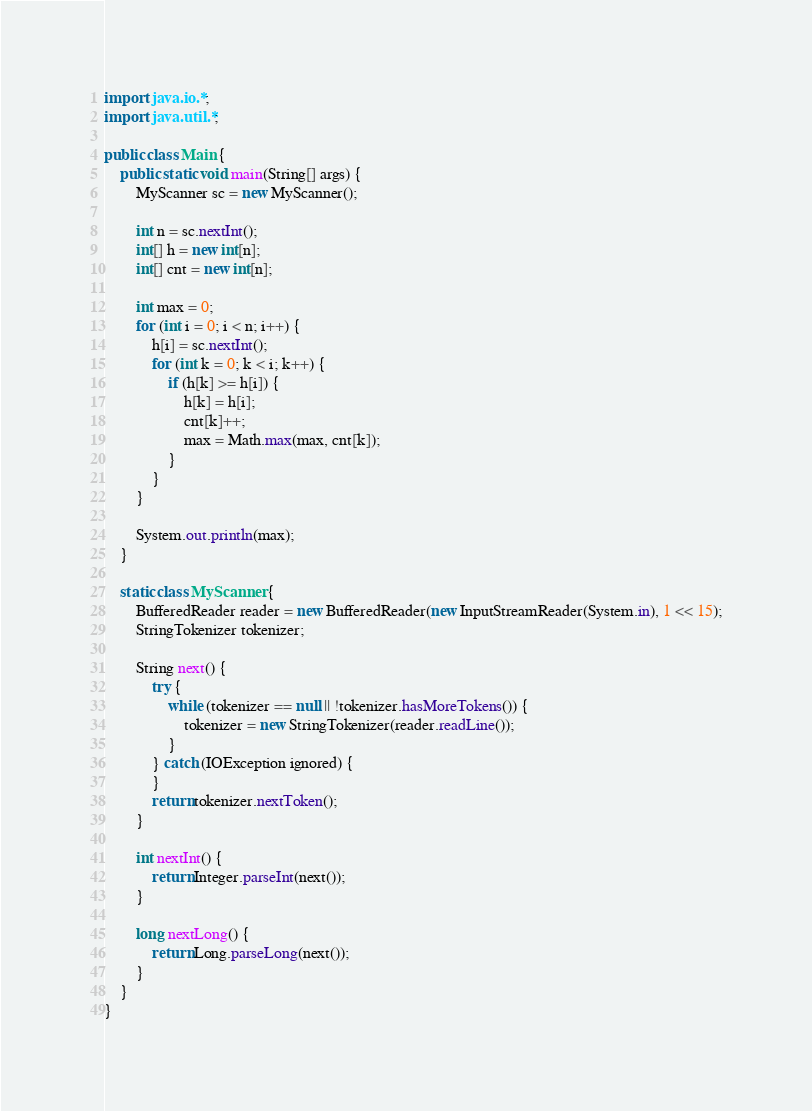Convert code to text. <code><loc_0><loc_0><loc_500><loc_500><_Java_>import java.io.*;
import java.util.*;

public class Main {
    public static void main(String[] args) {
        MyScanner sc = new MyScanner();

        int n = sc.nextInt();
        int[] h = new int[n];
        int[] cnt = new int[n];

        int max = 0;
        for (int i = 0; i < n; i++) {
            h[i] = sc.nextInt();
            for (int k = 0; k < i; k++) {
                if (h[k] >= h[i]) {
                    h[k] = h[i];
                    cnt[k]++;
                    max = Math.max(max, cnt[k]);
                }
            }
        }

        System.out.println(max);
    }

    static class MyScanner {
        BufferedReader reader = new BufferedReader(new InputStreamReader(System.in), 1 << 15);
        StringTokenizer tokenizer;

        String next() {
            try {
                while (tokenizer == null || !tokenizer.hasMoreTokens()) {
                    tokenizer = new StringTokenizer(reader.readLine());
                }
            } catch (IOException ignored) {
            }
            return tokenizer.nextToken();
        }

        int nextInt() {
            return Integer.parseInt(next());
        }

        long nextLong() {
            return Long.parseLong(next());
        }
    }
}</code> 